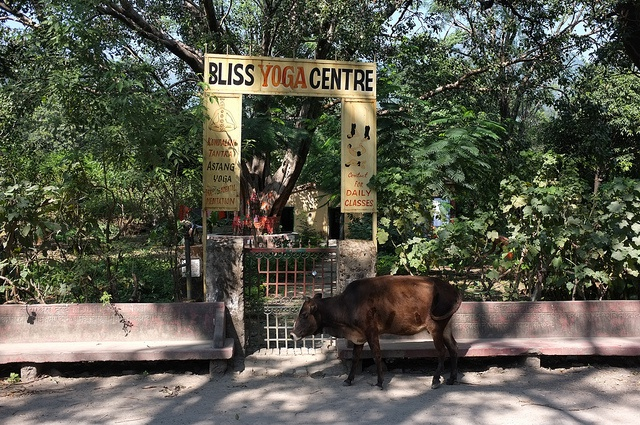Describe the objects in this image and their specific colors. I can see bench in black, lightgray, tan, darkgray, and gray tones, cow in black, maroon, brown, and gray tones, and bench in black, gray, darkgray, and pink tones in this image. 